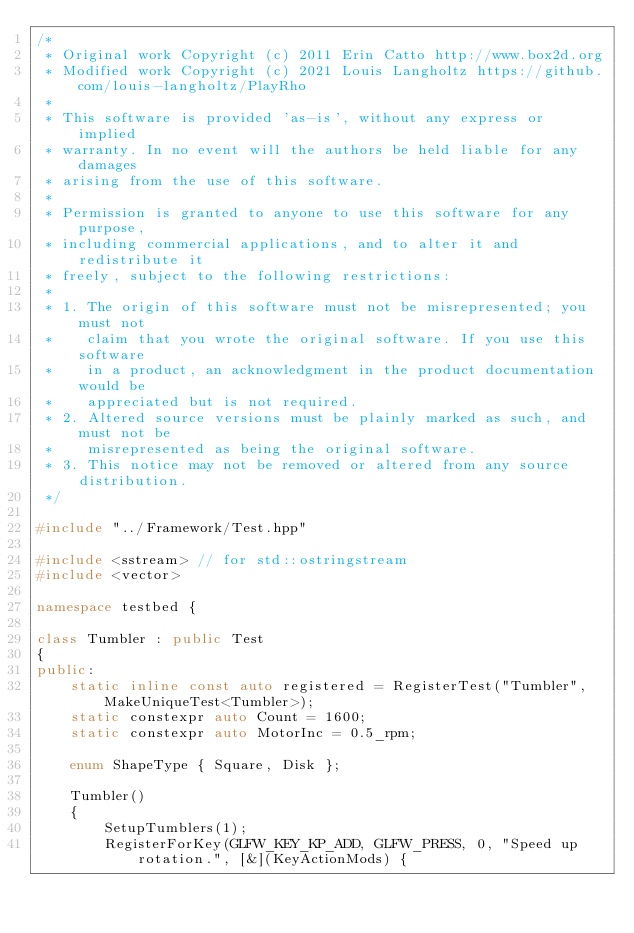Convert code to text. <code><loc_0><loc_0><loc_500><loc_500><_C++_>/*
 * Original work Copyright (c) 2011 Erin Catto http://www.box2d.org
 * Modified work Copyright (c) 2021 Louis Langholtz https://github.com/louis-langholtz/PlayRho
 *
 * This software is provided 'as-is', without any express or implied
 * warranty. In no event will the authors be held liable for any damages
 * arising from the use of this software.
 *
 * Permission is granted to anyone to use this software for any purpose,
 * including commercial applications, and to alter it and redistribute it
 * freely, subject to the following restrictions:
 *
 * 1. The origin of this software must not be misrepresented; you must not
 *    claim that you wrote the original software. If you use this software
 *    in a product, an acknowledgment in the product documentation would be
 *    appreciated but is not required.
 * 2. Altered source versions must be plainly marked as such, and must not be
 *    misrepresented as being the original software.
 * 3. This notice may not be removed or altered from any source distribution.
 */

#include "../Framework/Test.hpp"

#include <sstream> // for std::ostringstream
#include <vector>

namespace testbed {

class Tumbler : public Test
{
public:
    static inline const auto registered = RegisterTest("Tumbler", MakeUniqueTest<Tumbler>);
    static constexpr auto Count = 1600;
    static constexpr auto MotorInc = 0.5_rpm;

    enum ShapeType { Square, Disk };

    Tumbler()
    {
        SetupTumblers(1);
        RegisterForKey(GLFW_KEY_KP_ADD, GLFW_PRESS, 0, "Speed up rotation.", [&](KeyActionMods) {</code> 